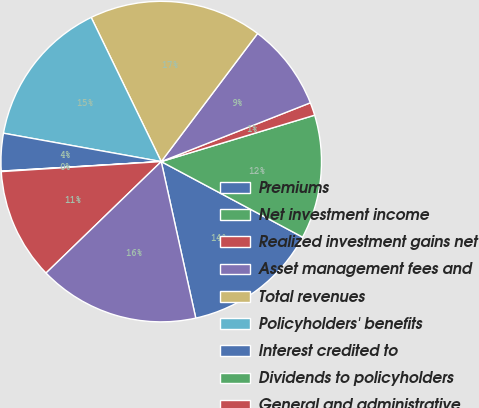Convert chart to OTSL. <chart><loc_0><loc_0><loc_500><loc_500><pie_chart><fcel>Premiums<fcel>Net investment income<fcel>Realized investment gains net<fcel>Asset management fees and<fcel>Total revenues<fcel>Policyholders' benefits<fcel>Interest credited to<fcel>Dividends to policyholders<fcel>General and administrative<fcel>Total benefits and expenses<nl><fcel>13.73%<fcel>12.49%<fcel>1.3%<fcel>8.76%<fcel>17.46%<fcel>14.97%<fcel>3.78%<fcel>0.05%<fcel>11.24%<fcel>16.22%<nl></chart> 